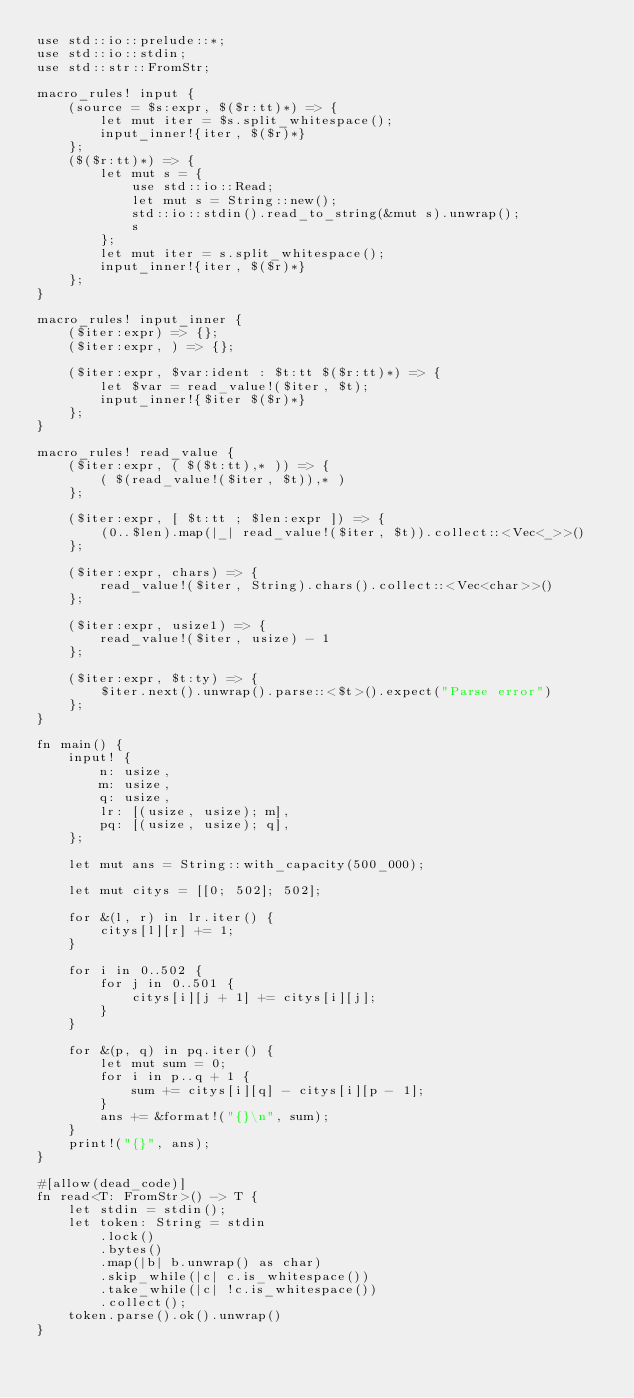<code> <loc_0><loc_0><loc_500><loc_500><_Rust_>use std::io::prelude::*;
use std::io::stdin;
use std::str::FromStr;

macro_rules! input {
    (source = $s:expr, $($r:tt)*) => {
        let mut iter = $s.split_whitespace();
        input_inner!{iter, $($r)*}
    };
    ($($r:tt)*) => {
        let mut s = {
            use std::io::Read;
            let mut s = String::new();
            std::io::stdin().read_to_string(&mut s).unwrap();
            s
        };
        let mut iter = s.split_whitespace();
        input_inner!{iter, $($r)*}
    };
}

macro_rules! input_inner {
    ($iter:expr) => {};
    ($iter:expr, ) => {};

    ($iter:expr, $var:ident : $t:tt $($r:tt)*) => {
        let $var = read_value!($iter, $t);
        input_inner!{$iter $($r)*}
    };
}

macro_rules! read_value {
    ($iter:expr, ( $($t:tt),* )) => {
        ( $(read_value!($iter, $t)),* )
    };

    ($iter:expr, [ $t:tt ; $len:expr ]) => {
        (0..$len).map(|_| read_value!($iter, $t)).collect::<Vec<_>>()
    };

    ($iter:expr, chars) => {
        read_value!($iter, String).chars().collect::<Vec<char>>()
    };

    ($iter:expr, usize1) => {
        read_value!($iter, usize) - 1
    };

    ($iter:expr, $t:ty) => {
        $iter.next().unwrap().parse::<$t>().expect("Parse error")
    };
}

fn main() {
    input! {
        n: usize,
        m: usize,
        q: usize,
        lr: [(usize, usize); m],
        pq: [(usize, usize); q],
    };

    let mut ans = String::with_capacity(500_000);

    let mut citys = [[0; 502]; 502];

    for &(l, r) in lr.iter() {
        citys[l][r] += 1;
    }

    for i in 0..502 {
        for j in 0..501 {
            citys[i][j + 1] += citys[i][j];
        }
    }

    for &(p, q) in pq.iter() {
        let mut sum = 0;
        for i in p..q + 1 {
            sum += citys[i][q] - citys[i][p - 1];
        }
        ans += &format!("{}\n", sum);
    }
    print!("{}", ans);
}

#[allow(dead_code)]
fn read<T: FromStr>() -> T {
    let stdin = stdin();
    let token: String = stdin
        .lock()
        .bytes()
        .map(|b| b.unwrap() as char)
        .skip_while(|c| c.is_whitespace())
        .take_while(|c| !c.is_whitespace())
        .collect();
    token.parse().ok().unwrap()
}
</code> 